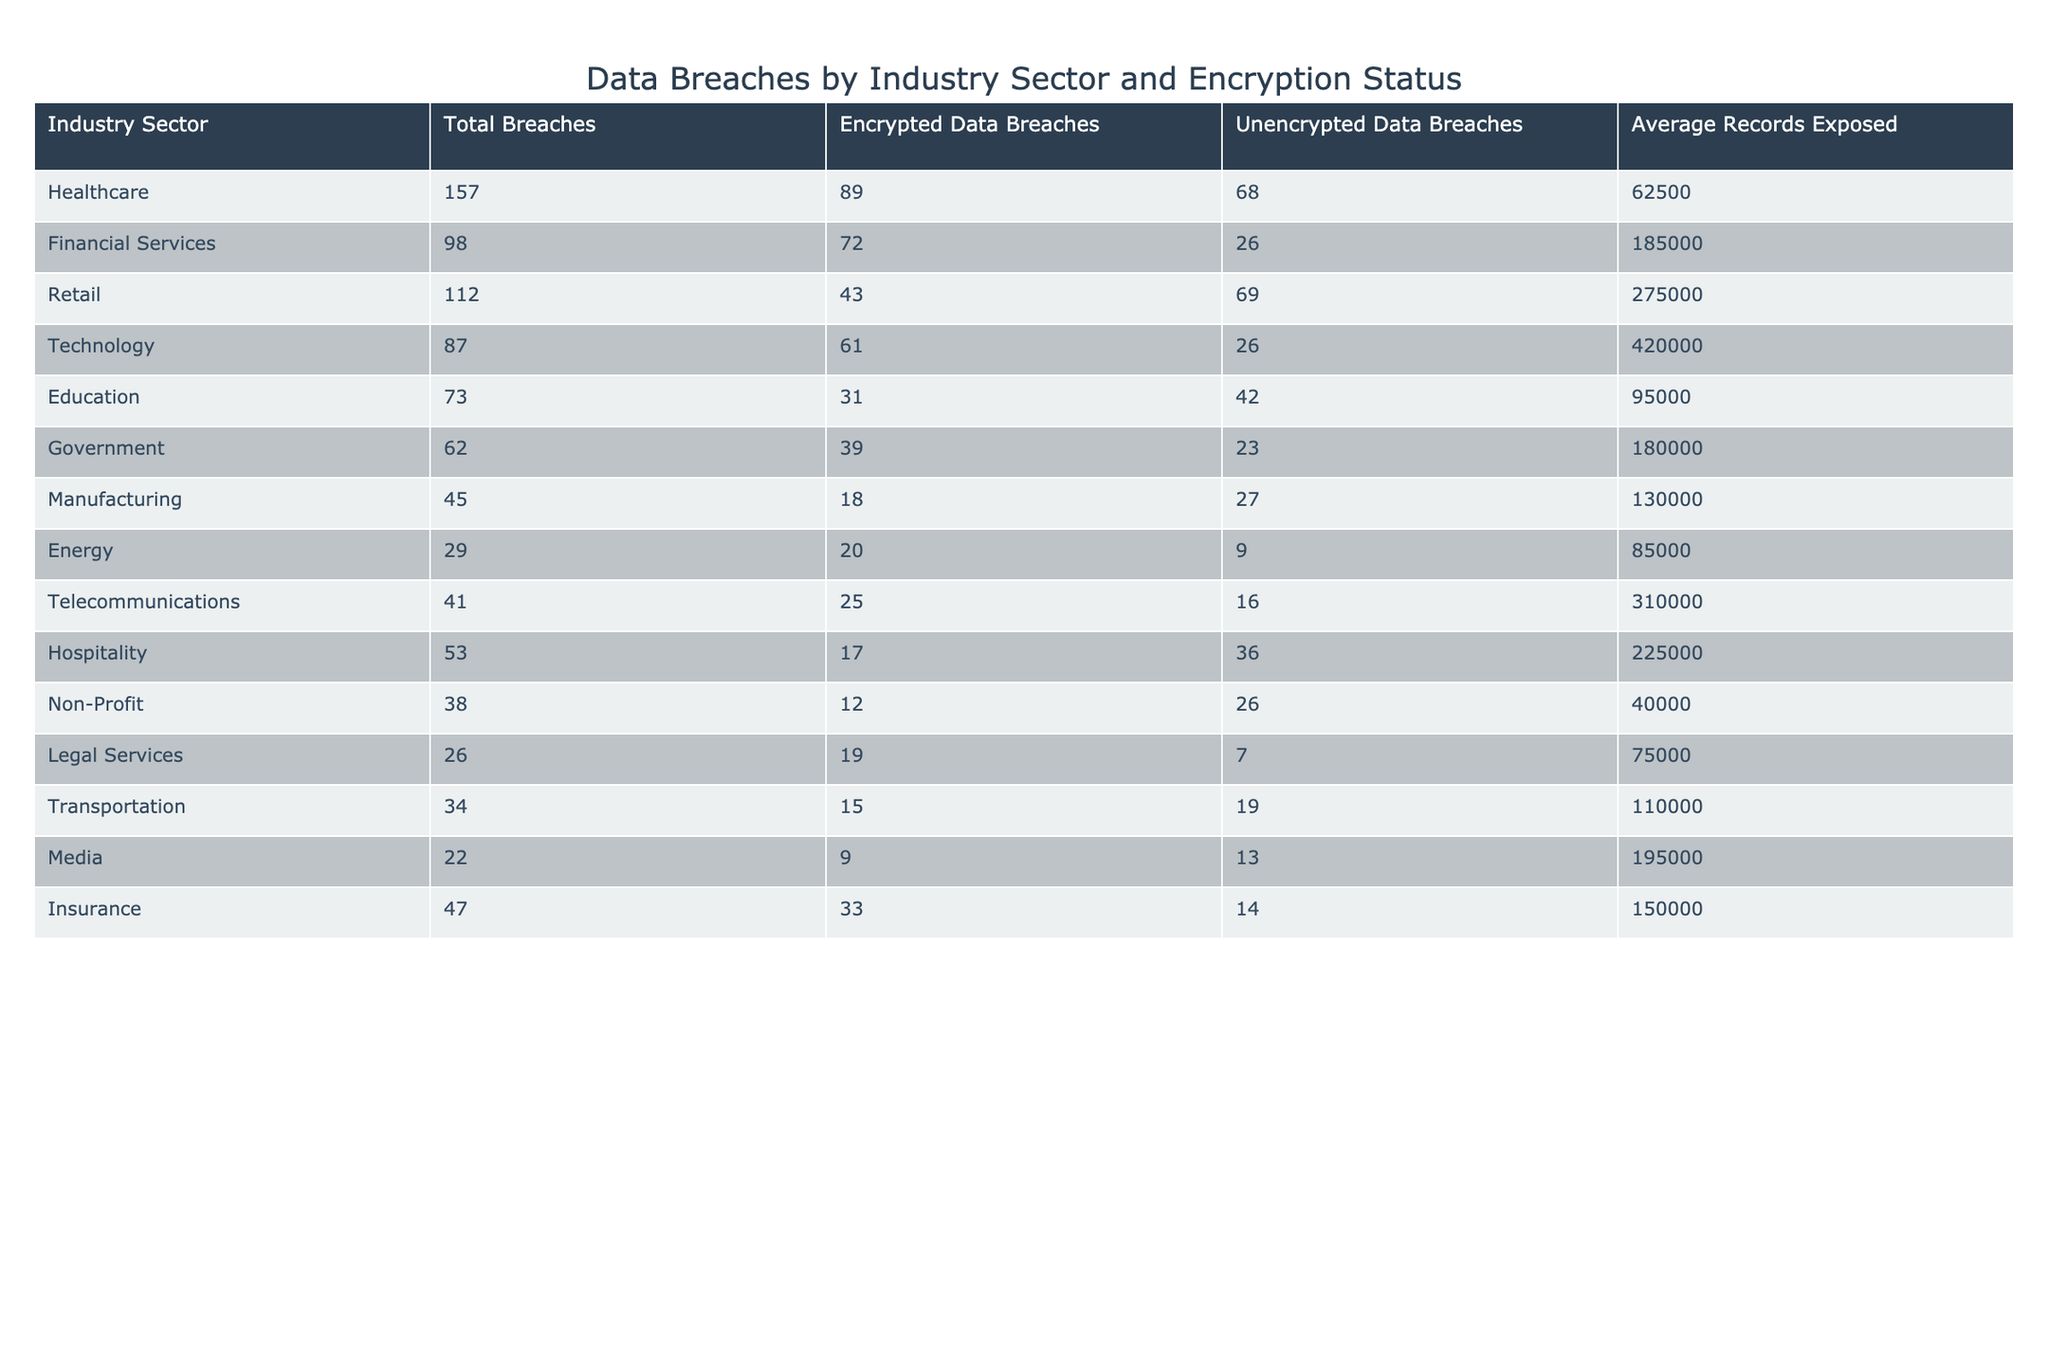What industry sector has the most total breaches? Looking at the "Total Breaches" column, the healthcare sector has the highest total with 157 breaches.
Answer: Healthcare How many data breaches in the technology sector were unencrypted? The technology sector has 26 unencrypted data breaches as indicated in the relevant column.
Answer: 26 Which industry has the least amount of data breaches? The media sector has the least total breaches with only 22, according to the "Total Breaches" column.
Answer: Media What is the difference between encrypted and unencrypted breaches in the healthcare sector? In the healthcare sector, there are 89 encrypted breaches and 68 unencrypted breaches. The difference is 89 - 68 = 21.
Answer: 21 What is the average number of records exposed in the retail sector? The table shows that the average records exposed in the retail sector is 275,000.
Answer: 275000 Which industry sector has the highest average records exposed? By comparing the "Average Records Exposed" values, the technology sector has the highest average at 420,000 records.
Answer: Technology Does the financial services sector have more encrypted data breaches than the transportation sector? The financial services sector has 72 encrypted breaches, while the transportation sector has 15, which indicates that financial services has more.
Answer: Yes What is the total number of unencrypted data breaches across the healthcare and education sectors? The healthcare sector has 68 unencrypted breaches and the education sector has 42. Adding these gives 68 + 42 = 110.
Answer: 110 In which industry sector is the average records exposed less than 100,000? The sectors with averages less than 100,000 are energy (85,000) and non-profit (40,000) as seen in the "Average Records Exposed" column.
Answer: Energy and Non-Profit Which sector has more than half of its breaches encrypted? The healthcare (89 encrypted), financial services (72 encrypted), technology (61 encrypted), government (39 encrypted), and insurance (33 encrypted) sectors all have more than half of their breaches encrypted.
Answer: Multiple sectors: Healthcare, Financial Services, Technology, Government, Insurance 